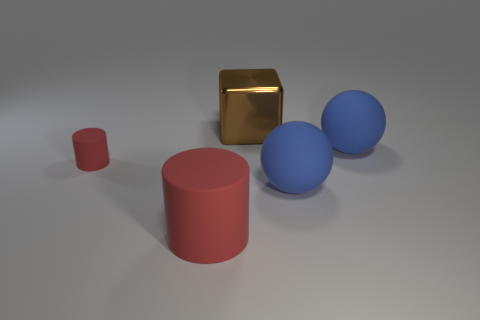How would you describe the composition and balance of this image? The composition of this image displays a thoughtful asymmetry. The placement of objects forms a loose triangular arrangement, providing balance without perfect symmetry. This creates a visually pleasing scene with a clear focus, guiding the viewer's eye from one object to another. The varied shapes and sizes of the objects contribute to a dynamic yet harmonious balance. 